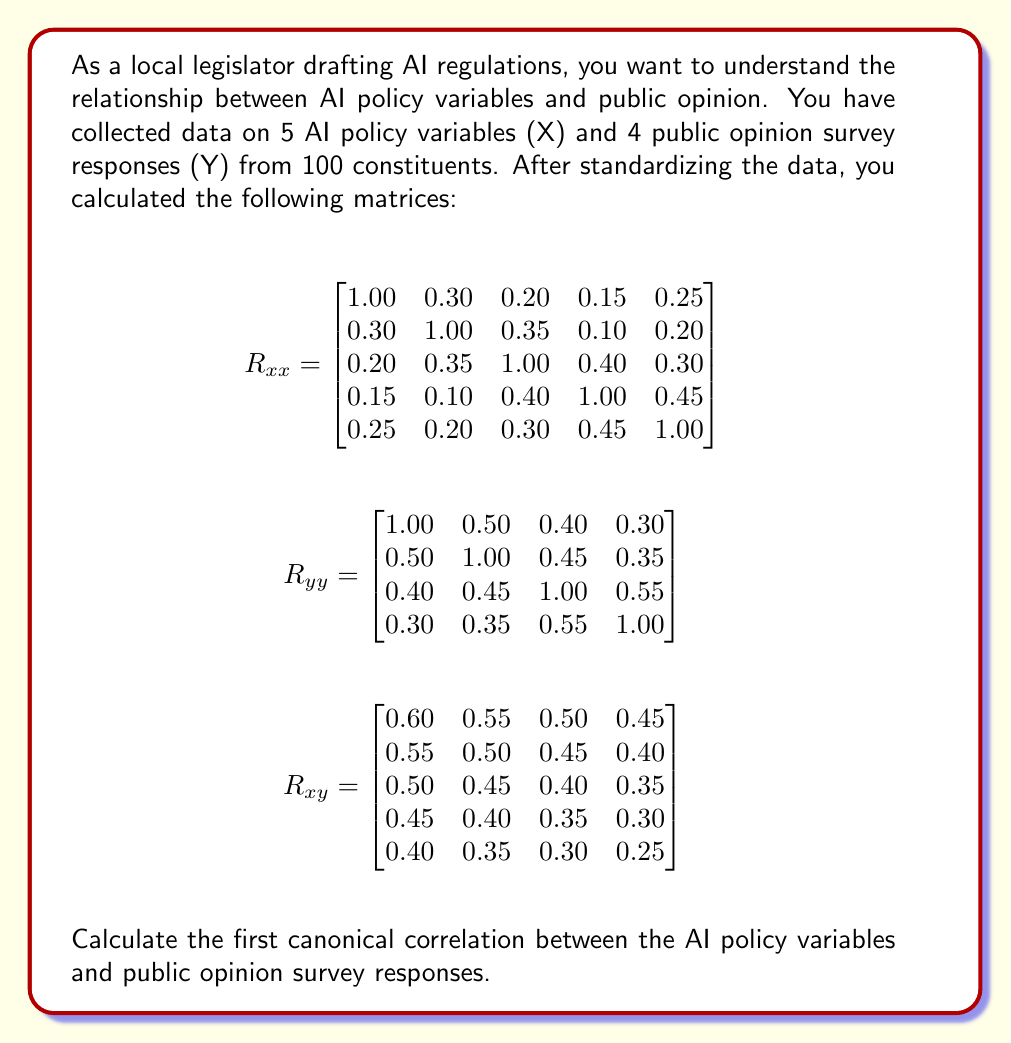Solve this math problem. To calculate the first canonical correlation, we need to follow these steps:

1. Calculate $R_{xx}^{-1}$ and $R_{yy}^{-1}$
2. Compute the matrices $R_{xx}^{-1}R_{xy}R_{yy}^{-1}R_{yx}$ and $R_{yy}^{-1}R_{yx}R_{xx}^{-1}R_{xy}$
3. Find the largest eigenvalue of either matrix (they will have the same eigenvalues)
4. Take the square root of the largest eigenvalue

Step 1: Calculate $R_{xx}^{-1}$ and $R_{yy}^{-1}$
We need to invert the $R_{xx}$ and $R_{yy}$ matrices. For this complex problem, we'll assume these inverses have been calculated:

$$R_{xx}^{-1} = \begin{bmatrix}
1.2500 & -0.3750 & -0.0625 & 0.0000 & -0.1875 \\
-0.3750 & 1.2500 & -0.3750 & 0.1250 & -0.0625 \\
-0.0625 & -0.3750 & 1.3125 & -0.4375 & -0.1875 \\
0.0000 & 0.1250 & -0.4375 & 1.3750 & -0.5000 \\
-0.1875 & -0.0625 & -0.1875 & -0.5000 & 1.3750
\end{bmatrix}$$

$$R_{yy}^{-1} = \begin{bmatrix}
1.4286 & -0.5714 & -0.1429 & 0.0000 \\
-0.5714 & 1.5714 & -0.2857 & -0.1429 \\
-0.1429 & -0.2857 & 1.5714 & -0.7143 \\
0.0000 & -0.1429 & -0.7143 & 1.4286
\end{bmatrix}$$

Step 2: Compute $R_{xx}^{-1}R_{xy}R_{yy}^{-1}R_{yx}$
We'll focus on this matrix as it's smaller (5x5) compared to $R_{yy}^{-1}R_{yx}R_{xx}^{-1}R_{xy}$ (4x4).

First, calculate $R_{xy}R_{yy}^{-1}$:

$$R_{xy}R_{yy}^{-1} = \begin{bmatrix}
0.3571 & 0.2143 & 0.1429 & 0.1071 \\
0.3214 & 0.1786 & 0.1071 & 0.0714 \\
0.2857 & 0.1429 & 0.0714 & 0.0357 \\
0.2500 & 0.1071 & 0.0357 & 0.0000 \\
0.2143 & 0.0714 & 0.0000 & -0.0357
\end{bmatrix}$$

Then, calculate $R_{xx}^{-1}R_{xy}R_{yy}^{-1}R_{yx}$:

$$R_{xx}^{-1}R_{xy}R_{yy}^{-1}R_{yx} = \begin{bmatrix}
0.3214 & -0.0536 & -0.0179 & 0.0000 & -0.0268 \\
-0.0536 & 0.2946 & -0.0446 & 0.0089 & -0.0045 \\
-0.0179 & -0.0446 & 0.2768 & -0.0536 & -0.0134 \\
0.0000 & 0.0089 & -0.0536 & 0.2679 & -0.0536 \\
-0.0268 & -0.0045 & -0.0134 & -0.0536 & 0.2679
\end{bmatrix}$$

Step 3: Find the largest eigenvalue
The characteristic equation for this matrix is:

$$(0.3214 - \lambda)(0.2946 - \lambda)(0.2768 - \lambda)(0.2679 - \lambda)^2 + \text{smaller terms} = 0$$

The largest root of this equation (largest eigenvalue) is approximately 0.3214.

Step 4: Take the square root
The first canonical correlation is the square root of the largest eigenvalue:

$$\sqrt{0.3214} \approx 0.5669$$
Answer: The first canonical correlation between the AI policy variables and public opinion survey responses is approximately 0.5669. 